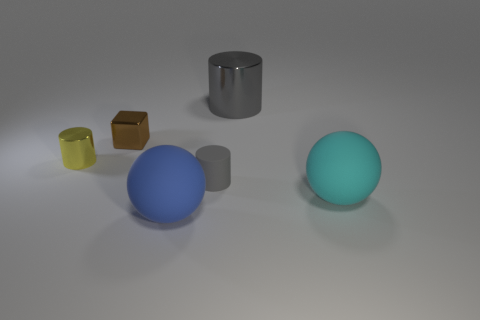Subtract all gray cylinders. How many cylinders are left? 1 Subtract 1 balls. How many balls are left? 1 Add 3 tiny cubes. How many objects exist? 9 Subtract all yellow cylinders. How many cylinders are left? 2 Subtract 0 brown cylinders. How many objects are left? 6 Subtract all blocks. How many objects are left? 5 Subtract all blue cubes. Subtract all green cylinders. How many cubes are left? 1 Subtract all blue cylinders. How many blue balls are left? 1 Subtract all big gray things. Subtract all cubes. How many objects are left? 4 Add 5 metallic things. How many metallic things are left? 8 